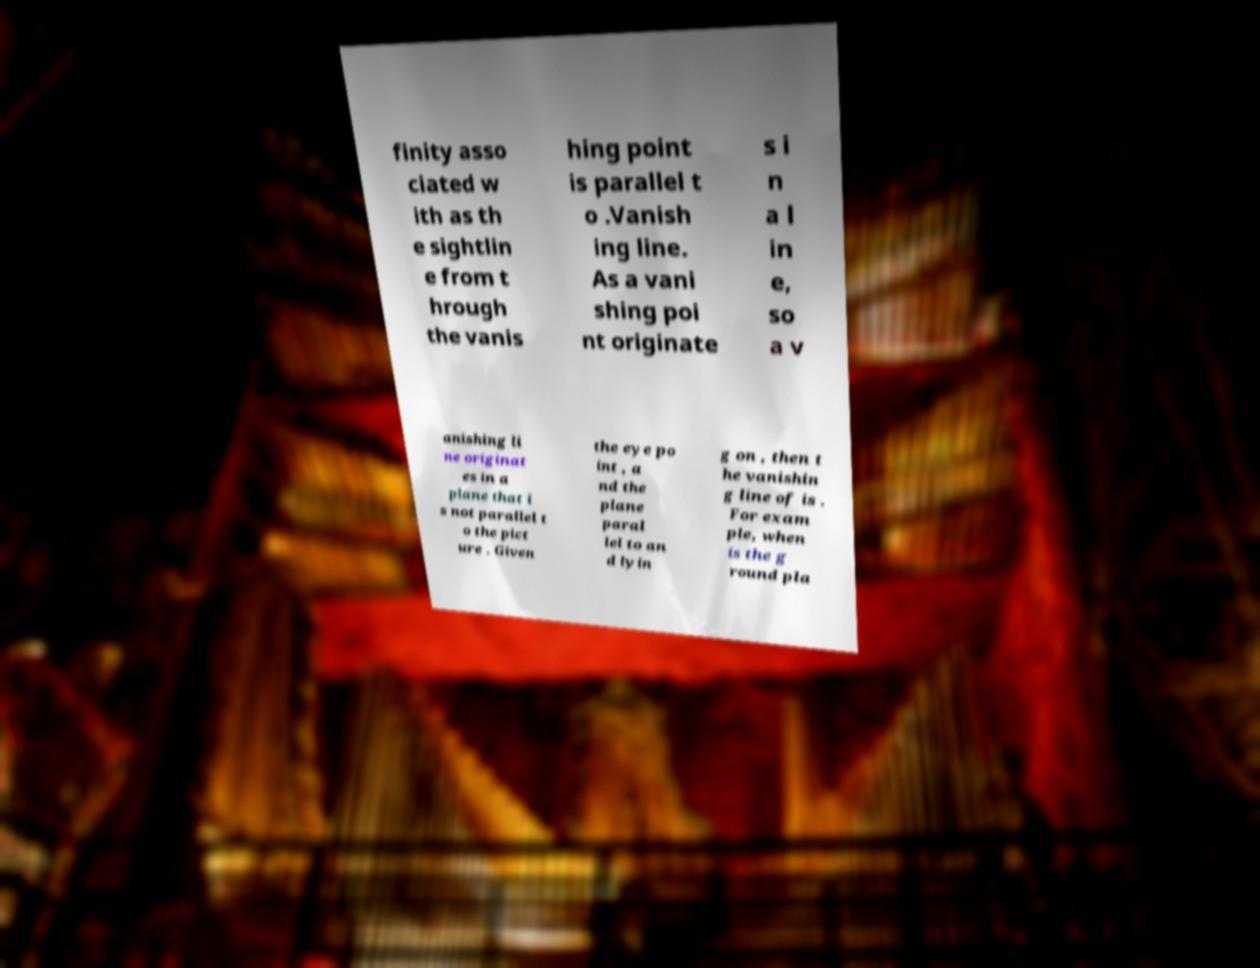Please read and relay the text visible in this image. What does it say? finity asso ciated w ith as th e sightlin e from t hrough the vanis hing point is parallel t o .Vanish ing line. As a vani shing poi nt originate s i n a l in e, so a v anishing li ne originat es in a plane that i s not parallel t o the pict ure . Given the eye po int , a nd the plane paral lel to an d lyin g on , then t he vanishin g line of is . For exam ple, when is the g round pla 